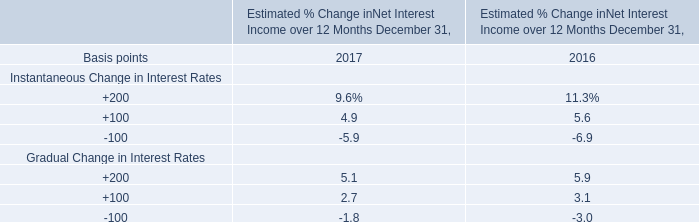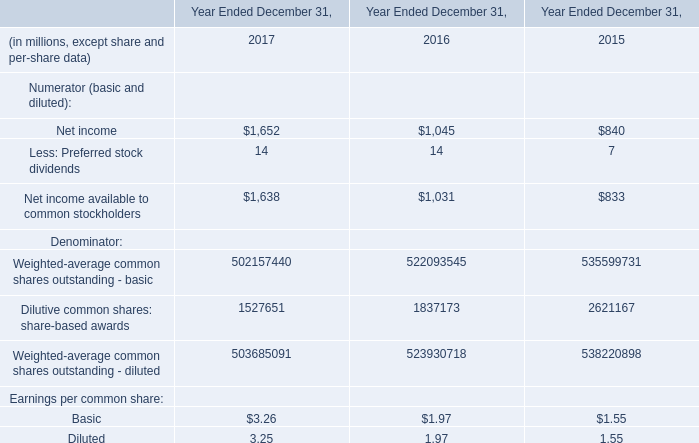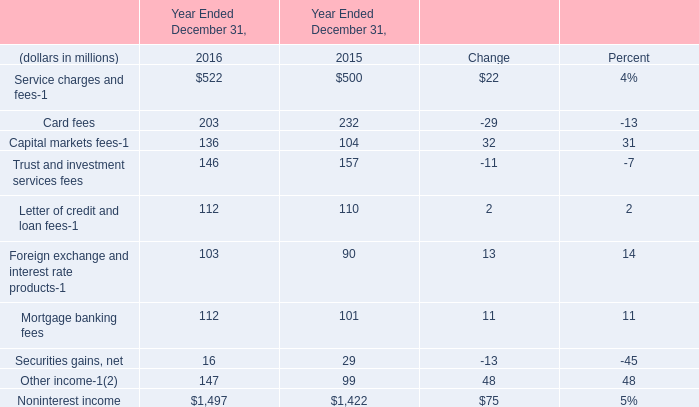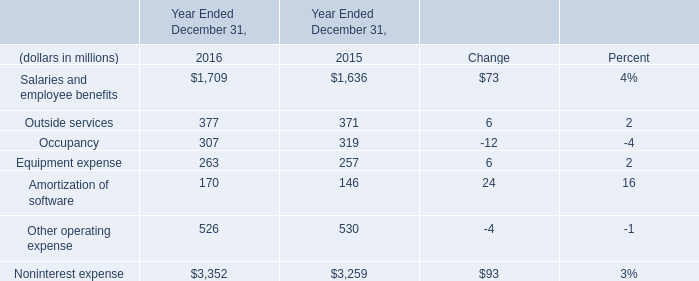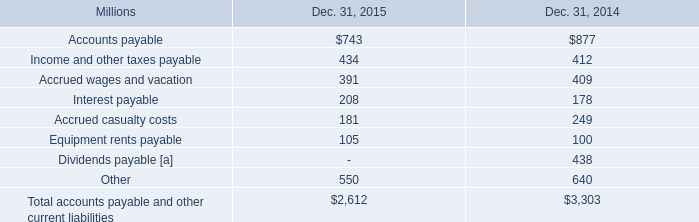How long does Salaries and employee benefits keep growing? 
Answer: 1 year. 